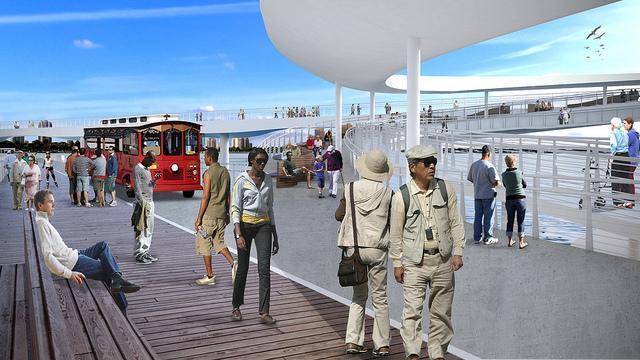How many people are in the picture?
Give a very brief answer. 6. 